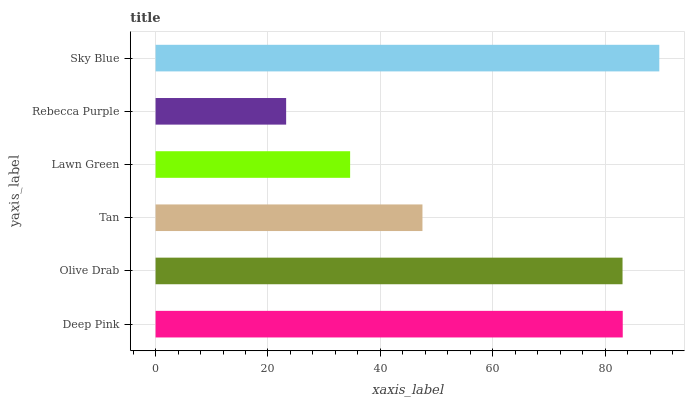Is Rebecca Purple the minimum?
Answer yes or no. Yes. Is Sky Blue the maximum?
Answer yes or no. Yes. Is Olive Drab the minimum?
Answer yes or no. No. Is Olive Drab the maximum?
Answer yes or no. No. Is Deep Pink greater than Olive Drab?
Answer yes or no. Yes. Is Olive Drab less than Deep Pink?
Answer yes or no. Yes. Is Olive Drab greater than Deep Pink?
Answer yes or no. No. Is Deep Pink less than Olive Drab?
Answer yes or no. No. Is Olive Drab the high median?
Answer yes or no. Yes. Is Tan the low median?
Answer yes or no. Yes. Is Rebecca Purple the high median?
Answer yes or no. No. Is Rebecca Purple the low median?
Answer yes or no. No. 